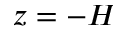<formula> <loc_0><loc_0><loc_500><loc_500>z = - H</formula> 